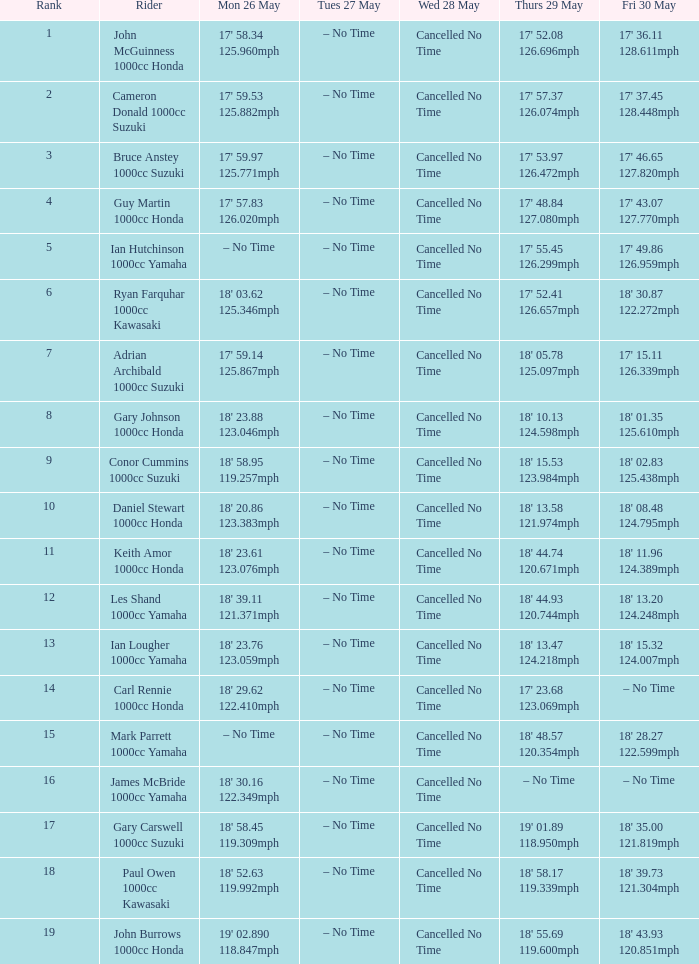Write the full table. {'header': ['Rank', 'Rider', 'Mon 26 May', 'Tues 27 May', 'Wed 28 May', 'Thurs 29 May', 'Fri 30 May'], 'rows': [['1', 'John McGuinness 1000cc Honda', "17' 58.34 125.960mph", '– No Time', 'Cancelled No Time', "17' 52.08 126.696mph", "17' 36.11 128.611mph"], ['2', 'Cameron Donald 1000cc Suzuki', "17' 59.53 125.882mph", '– No Time', 'Cancelled No Time', "17' 57.37 126.074mph", "17' 37.45 128.448mph"], ['3', 'Bruce Anstey 1000cc Suzuki', "17' 59.97 125.771mph", '– No Time', 'Cancelled No Time', "17' 53.97 126.472mph", "17' 46.65 127.820mph"], ['4', 'Guy Martin 1000cc Honda', "17' 57.83 126.020mph", '– No Time', 'Cancelled No Time', "17' 48.84 127.080mph", "17' 43.07 127.770mph"], ['5', 'Ian Hutchinson 1000cc Yamaha', '– No Time', '– No Time', 'Cancelled No Time', "17' 55.45 126.299mph", "17' 49.86 126.959mph"], ['6', 'Ryan Farquhar 1000cc Kawasaki', "18' 03.62 125.346mph", '– No Time', 'Cancelled No Time', "17' 52.41 126.657mph", "18' 30.87 122.272mph"], ['7', 'Adrian Archibald 1000cc Suzuki', "17' 59.14 125.867mph", '– No Time', 'Cancelled No Time', "18' 05.78 125.097mph", "17' 15.11 126.339mph"], ['8', 'Gary Johnson 1000cc Honda', "18' 23.88 123.046mph", '– No Time', 'Cancelled No Time', "18' 10.13 124.598mph", "18' 01.35 125.610mph"], ['9', 'Conor Cummins 1000cc Suzuki', "18' 58.95 119.257mph", '– No Time', 'Cancelled No Time', "18' 15.53 123.984mph", "18' 02.83 125.438mph"], ['10', 'Daniel Stewart 1000cc Honda', "18' 20.86 123.383mph", '– No Time', 'Cancelled No Time', "18' 13.58 121.974mph", "18' 08.48 124.795mph"], ['11', 'Keith Amor 1000cc Honda', "18' 23.61 123.076mph", '– No Time', 'Cancelled No Time', "18' 44.74 120.671mph", "18' 11.96 124.389mph"], ['12', 'Les Shand 1000cc Yamaha', "18' 39.11 121.371mph", '– No Time', 'Cancelled No Time', "18' 44.93 120.744mph", "18' 13.20 124.248mph"], ['13', 'Ian Lougher 1000cc Yamaha', "18' 23.76 123.059mph", '– No Time', 'Cancelled No Time', "18' 13.47 124.218mph", "18' 15.32 124.007mph"], ['14', 'Carl Rennie 1000cc Honda', "18' 29.62 122.410mph", '– No Time', 'Cancelled No Time', "17' 23.68 123.069mph", '– No Time'], ['15', 'Mark Parrett 1000cc Yamaha', '– No Time', '– No Time', 'Cancelled No Time', "18' 48.57 120.354mph", "18' 28.27 122.599mph"], ['16', 'James McBride 1000cc Yamaha', "18' 30.16 122.349mph", '– No Time', 'Cancelled No Time', '– No Time', '– No Time'], ['17', 'Gary Carswell 1000cc Suzuki', "18' 58.45 119.309mph", '– No Time', 'Cancelled No Time', "19' 01.89 118.950mph", "18' 35.00 121.819mph"], ['18', 'Paul Owen 1000cc Kawasaki', "18' 52.63 119.992mph", '– No Time', 'Cancelled No Time', "18' 58.17 119.339mph", "18' 39.73 121.304mph"], ['19', 'John Burrows 1000cc Honda', "19' 02.890 118.847mph", '– No Time', 'Cancelled No Time', "18' 55.69 119.600mph", "18' 43.93 120.851mph"]]} What tims is wed may 28 and mon may 26 is 17' 58.34 125.960mph? Cancelled No Time. 